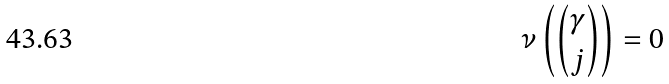Convert formula to latex. <formula><loc_0><loc_0><loc_500><loc_500>\nu \left ( \binom { \gamma } { j } \right ) = 0</formula> 